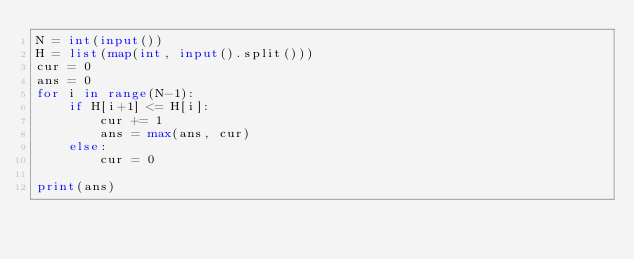<code> <loc_0><loc_0><loc_500><loc_500><_Python_>N = int(input())
H = list(map(int, input().split()))
cur = 0
ans = 0
for i in range(N-1):
    if H[i+1] <= H[i]:
        cur += 1
        ans = max(ans, cur)
    else:
        cur = 0

print(ans)
</code> 